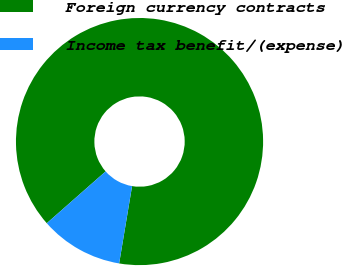Convert chart. <chart><loc_0><loc_0><loc_500><loc_500><pie_chart><fcel>Foreign currency contracts<fcel>Income tax benefit/(expense)<nl><fcel>89.13%<fcel>10.87%<nl></chart> 